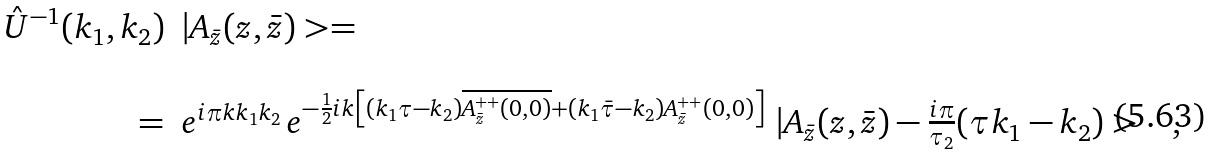Convert formula to latex. <formula><loc_0><loc_0><loc_500><loc_500>\begin{array} { r l } \hat { U } ^ { - 1 } ( k _ { 1 } , k _ { 2 } ) & | A _ { \bar { z } } ( z , \bar { z } ) > = \\ & \\ = & e ^ { i \pi k k _ { 1 } k _ { 2 } } \, e ^ { - \frac { 1 } { 2 } i k \left [ ( k _ { 1 } \tau - k _ { 2 } ) \overline { A _ { \bar { z } } ^ { + + } ( 0 , 0 ) } + ( k _ { 1 } \bar { \tau } - k _ { 2 } ) A _ { \bar { z } } ^ { + + } ( 0 , 0 ) \right ] } \ | A _ { \bar { z } } ( z , \bar { z } ) - \frac { i \pi } { \tau _ { 2 } } ( \tau k _ { 1 } - k _ { 2 } ) > \quad , \end{array}</formula> 